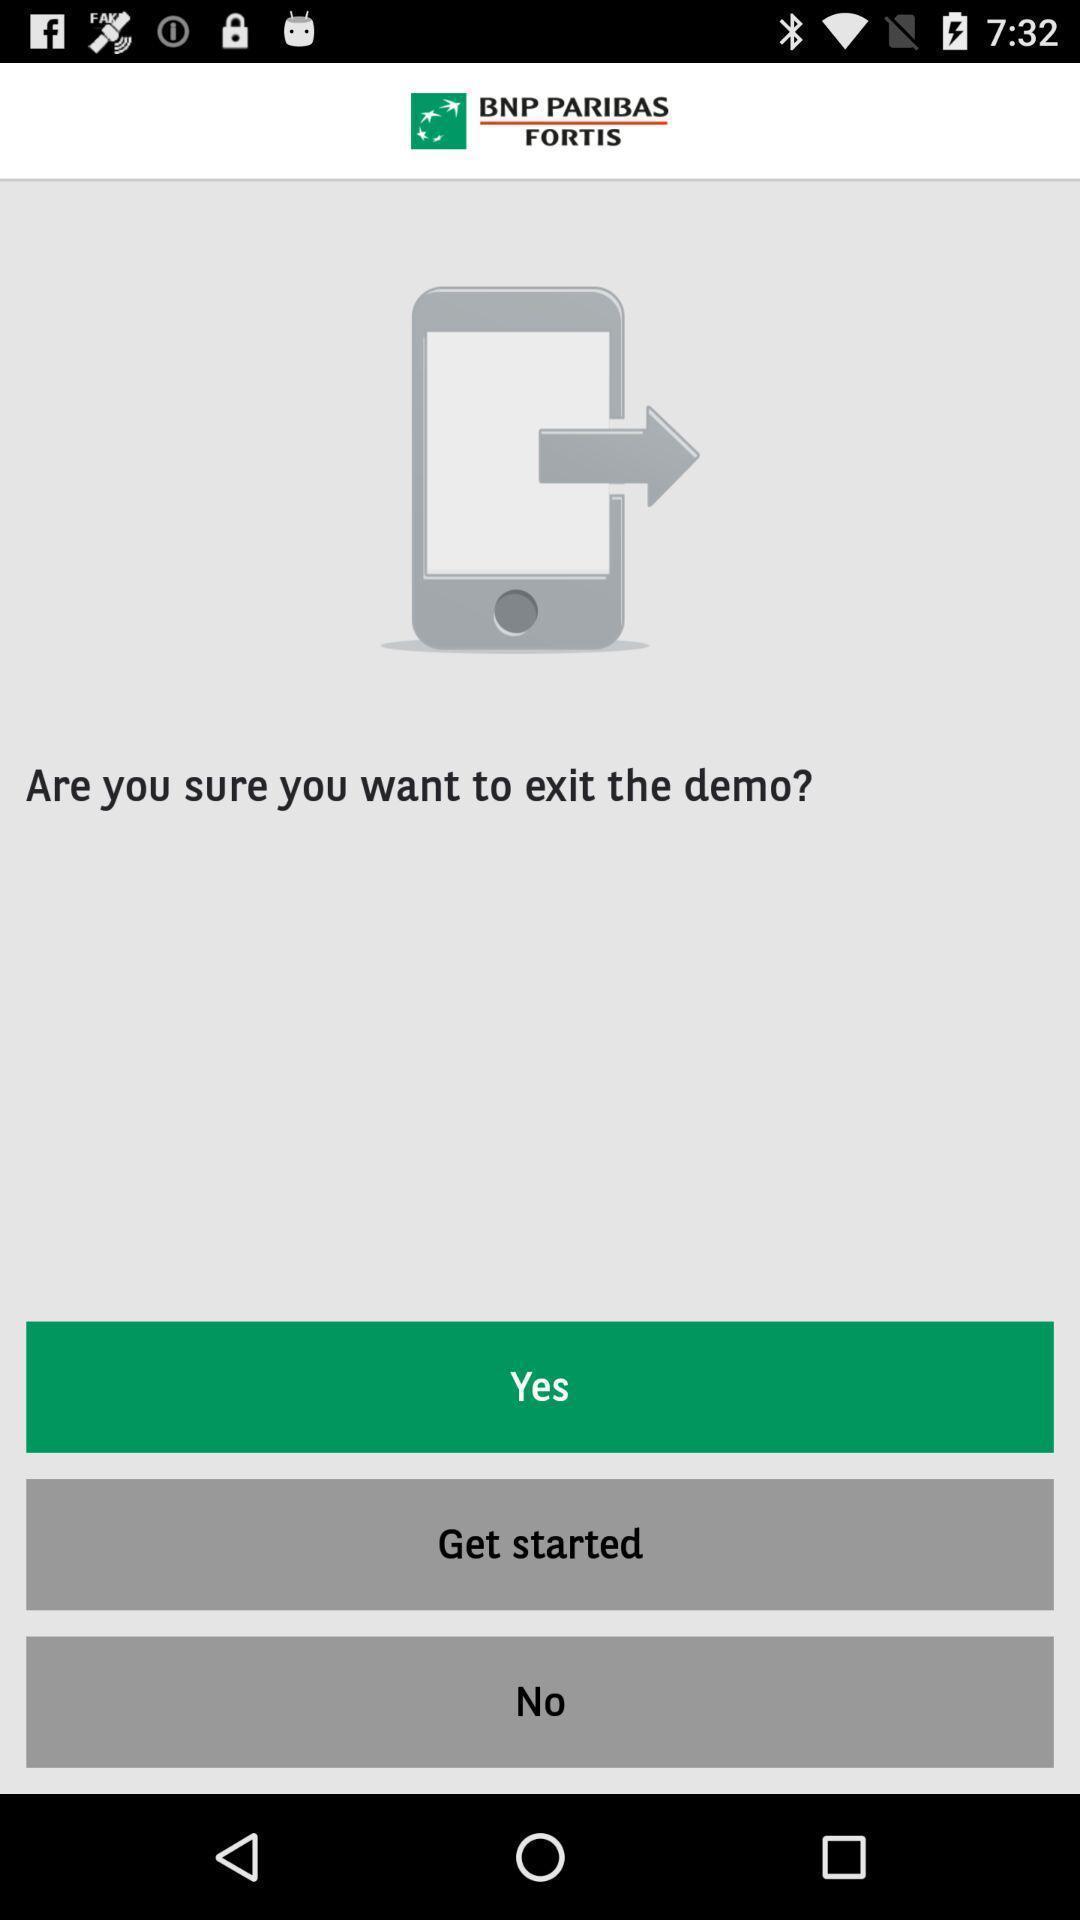Give me a summary of this screen capture. Screen shows multiple options. 